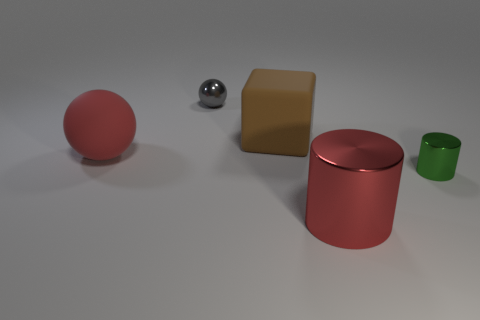Add 1 tiny shiny things. How many objects exist? 6 Subtract all spheres. How many objects are left? 3 Add 1 big gray cubes. How many big gray cubes exist? 1 Subtract 0 green blocks. How many objects are left? 5 Subtract all brown rubber things. Subtract all big matte blocks. How many objects are left? 3 Add 1 large matte balls. How many large matte balls are left? 2 